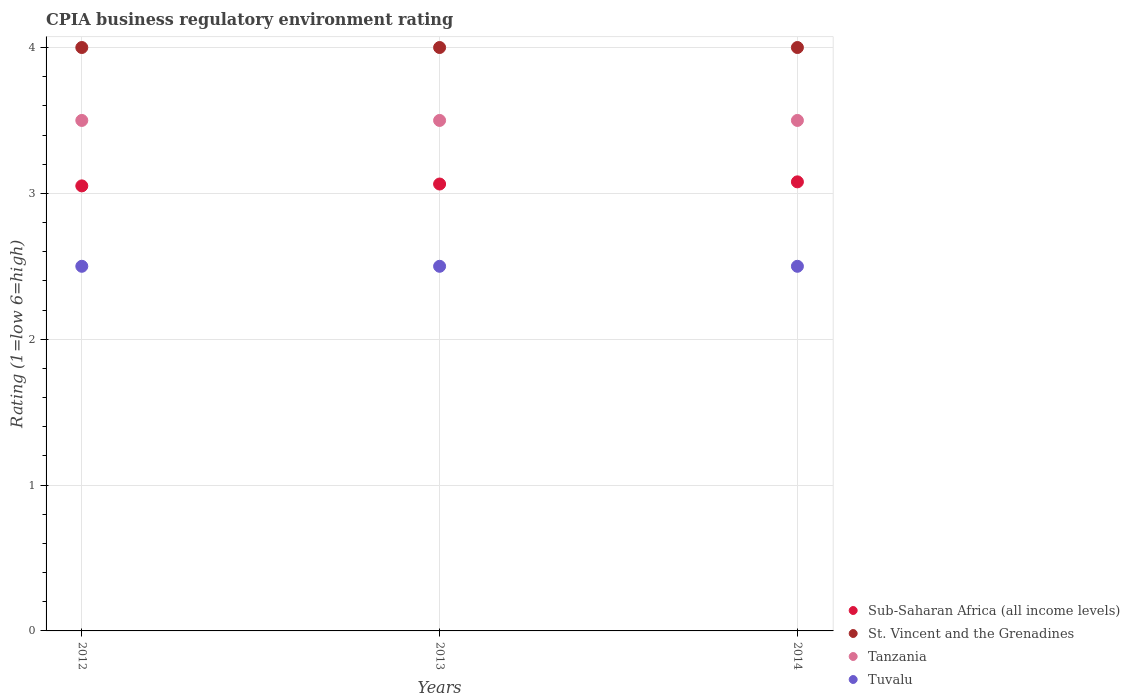How many different coloured dotlines are there?
Keep it short and to the point. 4. What is the CPIA rating in Sub-Saharan Africa (all income levels) in 2014?
Provide a succinct answer. 3.08. Across all years, what is the maximum CPIA rating in Sub-Saharan Africa (all income levels)?
Ensure brevity in your answer.  3.08. In which year was the CPIA rating in St. Vincent and the Grenadines maximum?
Offer a terse response. 2012. In which year was the CPIA rating in Sub-Saharan Africa (all income levels) minimum?
Offer a terse response. 2012. What is the difference between the CPIA rating in Tanzania in 2013 and that in 2014?
Ensure brevity in your answer.  0. What is the difference between the CPIA rating in Sub-Saharan Africa (all income levels) in 2014 and the CPIA rating in Tanzania in 2012?
Your response must be concise. -0.42. What is the average CPIA rating in Sub-Saharan Africa (all income levels) per year?
Provide a short and direct response. 3.06. What is the ratio of the CPIA rating in Tuvalu in 2013 to that in 2014?
Your answer should be very brief. 1. Is the CPIA rating in Tuvalu in 2012 less than that in 2014?
Ensure brevity in your answer.  No. Is the difference between the CPIA rating in St. Vincent and the Grenadines in 2013 and 2014 greater than the difference between the CPIA rating in Tuvalu in 2013 and 2014?
Give a very brief answer. No. What is the difference between the highest and the second highest CPIA rating in Sub-Saharan Africa (all income levels)?
Your answer should be compact. 0.01. What is the difference between the highest and the lowest CPIA rating in Sub-Saharan Africa (all income levels)?
Offer a terse response. 0.03. In how many years, is the CPIA rating in St. Vincent and the Grenadines greater than the average CPIA rating in St. Vincent and the Grenadines taken over all years?
Provide a short and direct response. 0. Is it the case that in every year, the sum of the CPIA rating in Sub-Saharan Africa (all income levels) and CPIA rating in St. Vincent and the Grenadines  is greater than the sum of CPIA rating in Tanzania and CPIA rating in Tuvalu?
Your answer should be compact. Yes. Is it the case that in every year, the sum of the CPIA rating in Sub-Saharan Africa (all income levels) and CPIA rating in Tanzania  is greater than the CPIA rating in St. Vincent and the Grenadines?
Offer a terse response. Yes. Does the CPIA rating in Tanzania monotonically increase over the years?
Offer a terse response. No. Is the CPIA rating in Sub-Saharan Africa (all income levels) strictly greater than the CPIA rating in Tanzania over the years?
Give a very brief answer. No. Is the CPIA rating in St. Vincent and the Grenadines strictly less than the CPIA rating in Tanzania over the years?
Offer a terse response. No. How many dotlines are there?
Ensure brevity in your answer.  4. How many years are there in the graph?
Offer a terse response. 3. What is the difference between two consecutive major ticks on the Y-axis?
Ensure brevity in your answer.  1. Does the graph contain any zero values?
Ensure brevity in your answer.  No. How many legend labels are there?
Your response must be concise. 4. What is the title of the graph?
Offer a very short reply. CPIA business regulatory environment rating. Does "Austria" appear as one of the legend labels in the graph?
Provide a succinct answer. No. What is the Rating (1=low 6=high) in Sub-Saharan Africa (all income levels) in 2012?
Your response must be concise. 3.05. What is the Rating (1=low 6=high) of St. Vincent and the Grenadines in 2012?
Provide a succinct answer. 4. What is the Rating (1=low 6=high) in Tuvalu in 2012?
Your response must be concise. 2.5. What is the Rating (1=low 6=high) in Sub-Saharan Africa (all income levels) in 2013?
Give a very brief answer. 3.06. What is the Rating (1=low 6=high) of Tanzania in 2013?
Your response must be concise. 3.5. What is the Rating (1=low 6=high) in Sub-Saharan Africa (all income levels) in 2014?
Your answer should be compact. 3.08. What is the Rating (1=low 6=high) in Tanzania in 2014?
Keep it short and to the point. 3.5. What is the Rating (1=low 6=high) in Tuvalu in 2014?
Give a very brief answer. 2.5. Across all years, what is the maximum Rating (1=low 6=high) in Sub-Saharan Africa (all income levels)?
Ensure brevity in your answer.  3.08. Across all years, what is the maximum Rating (1=low 6=high) in St. Vincent and the Grenadines?
Offer a very short reply. 4. Across all years, what is the maximum Rating (1=low 6=high) in Tanzania?
Keep it short and to the point. 3.5. Across all years, what is the minimum Rating (1=low 6=high) in Sub-Saharan Africa (all income levels)?
Your answer should be very brief. 3.05. Across all years, what is the minimum Rating (1=low 6=high) in St. Vincent and the Grenadines?
Make the answer very short. 4. Across all years, what is the minimum Rating (1=low 6=high) of Tanzania?
Your answer should be compact. 3.5. Across all years, what is the minimum Rating (1=low 6=high) in Tuvalu?
Your answer should be compact. 2.5. What is the total Rating (1=low 6=high) in Sub-Saharan Africa (all income levels) in the graph?
Provide a short and direct response. 9.19. What is the total Rating (1=low 6=high) of Tanzania in the graph?
Provide a succinct answer. 10.5. What is the difference between the Rating (1=low 6=high) in Sub-Saharan Africa (all income levels) in 2012 and that in 2013?
Ensure brevity in your answer.  -0.01. What is the difference between the Rating (1=low 6=high) in St. Vincent and the Grenadines in 2012 and that in 2013?
Make the answer very short. 0. What is the difference between the Rating (1=low 6=high) in Tanzania in 2012 and that in 2013?
Ensure brevity in your answer.  0. What is the difference between the Rating (1=low 6=high) in Sub-Saharan Africa (all income levels) in 2012 and that in 2014?
Your response must be concise. -0.03. What is the difference between the Rating (1=low 6=high) in St. Vincent and the Grenadines in 2012 and that in 2014?
Make the answer very short. 0. What is the difference between the Rating (1=low 6=high) in Sub-Saharan Africa (all income levels) in 2013 and that in 2014?
Offer a terse response. -0.01. What is the difference between the Rating (1=low 6=high) of St. Vincent and the Grenadines in 2013 and that in 2014?
Offer a terse response. 0. What is the difference between the Rating (1=low 6=high) in Tanzania in 2013 and that in 2014?
Offer a terse response. 0. What is the difference between the Rating (1=low 6=high) of Sub-Saharan Africa (all income levels) in 2012 and the Rating (1=low 6=high) of St. Vincent and the Grenadines in 2013?
Your response must be concise. -0.95. What is the difference between the Rating (1=low 6=high) of Sub-Saharan Africa (all income levels) in 2012 and the Rating (1=low 6=high) of Tanzania in 2013?
Keep it short and to the point. -0.45. What is the difference between the Rating (1=low 6=high) of Sub-Saharan Africa (all income levels) in 2012 and the Rating (1=low 6=high) of Tuvalu in 2013?
Ensure brevity in your answer.  0.55. What is the difference between the Rating (1=low 6=high) of Tanzania in 2012 and the Rating (1=low 6=high) of Tuvalu in 2013?
Give a very brief answer. 1. What is the difference between the Rating (1=low 6=high) in Sub-Saharan Africa (all income levels) in 2012 and the Rating (1=low 6=high) in St. Vincent and the Grenadines in 2014?
Make the answer very short. -0.95. What is the difference between the Rating (1=low 6=high) of Sub-Saharan Africa (all income levels) in 2012 and the Rating (1=low 6=high) of Tanzania in 2014?
Your response must be concise. -0.45. What is the difference between the Rating (1=low 6=high) in Sub-Saharan Africa (all income levels) in 2012 and the Rating (1=low 6=high) in Tuvalu in 2014?
Offer a very short reply. 0.55. What is the difference between the Rating (1=low 6=high) of Sub-Saharan Africa (all income levels) in 2013 and the Rating (1=low 6=high) of St. Vincent and the Grenadines in 2014?
Your answer should be compact. -0.94. What is the difference between the Rating (1=low 6=high) in Sub-Saharan Africa (all income levels) in 2013 and the Rating (1=low 6=high) in Tanzania in 2014?
Keep it short and to the point. -0.44. What is the difference between the Rating (1=low 6=high) of Sub-Saharan Africa (all income levels) in 2013 and the Rating (1=low 6=high) of Tuvalu in 2014?
Your answer should be very brief. 0.56. What is the difference between the Rating (1=low 6=high) in Tanzania in 2013 and the Rating (1=low 6=high) in Tuvalu in 2014?
Your response must be concise. 1. What is the average Rating (1=low 6=high) of Sub-Saharan Africa (all income levels) per year?
Provide a succinct answer. 3.06. In the year 2012, what is the difference between the Rating (1=low 6=high) in Sub-Saharan Africa (all income levels) and Rating (1=low 6=high) in St. Vincent and the Grenadines?
Give a very brief answer. -0.95. In the year 2012, what is the difference between the Rating (1=low 6=high) of Sub-Saharan Africa (all income levels) and Rating (1=low 6=high) of Tanzania?
Provide a succinct answer. -0.45. In the year 2012, what is the difference between the Rating (1=low 6=high) in Sub-Saharan Africa (all income levels) and Rating (1=low 6=high) in Tuvalu?
Ensure brevity in your answer.  0.55. In the year 2013, what is the difference between the Rating (1=low 6=high) in Sub-Saharan Africa (all income levels) and Rating (1=low 6=high) in St. Vincent and the Grenadines?
Provide a succinct answer. -0.94. In the year 2013, what is the difference between the Rating (1=low 6=high) of Sub-Saharan Africa (all income levels) and Rating (1=low 6=high) of Tanzania?
Make the answer very short. -0.44. In the year 2013, what is the difference between the Rating (1=low 6=high) of Sub-Saharan Africa (all income levels) and Rating (1=low 6=high) of Tuvalu?
Keep it short and to the point. 0.56. In the year 2013, what is the difference between the Rating (1=low 6=high) of St. Vincent and the Grenadines and Rating (1=low 6=high) of Tanzania?
Give a very brief answer. 0.5. In the year 2013, what is the difference between the Rating (1=low 6=high) in Tanzania and Rating (1=low 6=high) in Tuvalu?
Your answer should be compact. 1. In the year 2014, what is the difference between the Rating (1=low 6=high) in Sub-Saharan Africa (all income levels) and Rating (1=low 6=high) in St. Vincent and the Grenadines?
Offer a terse response. -0.92. In the year 2014, what is the difference between the Rating (1=low 6=high) of Sub-Saharan Africa (all income levels) and Rating (1=low 6=high) of Tanzania?
Offer a very short reply. -0.42. In the year 2014, what is the difference between the Rating (1=low 6=high) in Sub-Saharan Africa (all income levels) and Rating (1=low 6=high) in Tuvalu?
Your answer should be compact. 0.58. In the year 2014, what is the difference between the Rating (1=low 6=high) in St. Vincent and the Grenadines and Rating (1=low 6=high) in Tuvalu?
Offer a terse response. 1.5. What is the ratio of the Rating (1=low 6=high) of Sub-Saharan Africa (all income levels) in 2012 to that in 2013?
Your answer should be compact. 1. What is the ratio of the Rating (1=low 6=high) in St. Vincent and the Grenadines in 2012 to that in 2013?
Keep it short and to the point. 1. What is the ratio of the Rating (1=low 6=high) in Tuvalu in 2012 to that in 2013?
Ensure brevity in your answer.  1. What is the ratio of the Rating (1=low 6=high) of Sub-Saharan Africa (all income levels) in 2012 to that in 2014?
Offer a very short reply. 0.99. What is the ratio of the Rating (1=low 6=high) of St. Vincent and the Grenadines in 2012 to that in 2014?
Make the answer very short. 1. What is the ratio of the Rating (1=low 6=high) of Tanzania in 2012 to that in 2014?
Give a very brief answer. 1. What is the ratio of the Rating (1=low 6=high) of St. Vincent and the Grenadines in 2013 to that in 2014?
Your response must be concise. 1. What is the ratio of the Rating (1=low 6=high) in Tanzania in 2013 to that in 2014?
Give a very brief answer. 1. What is the difference between the highest and the second highest Rating (1=low 6=high) of Sub-Saharan Africa (all income levels)?
Your answer should be compact. 0.01. What is the difference between the highest and the lowest Rating (1=low 6=high) in Sub-Saharan Africa (all income levels)?
Give a very brief answer. 0.03. What is the difference between the highest and the lowest Rating (1=low 6=high) in St. Vincent and the Grenadines?
Your answer should be compact. 0. What is the difference between the highest and the lowest Rating (1=low 6=high) in Tanzania?
Provide a succinct answer. 0. What is the difference between the highest and the lowest Rating (1=low 6=high) in Tuvalu?
Keep it short and to the point. 0. 